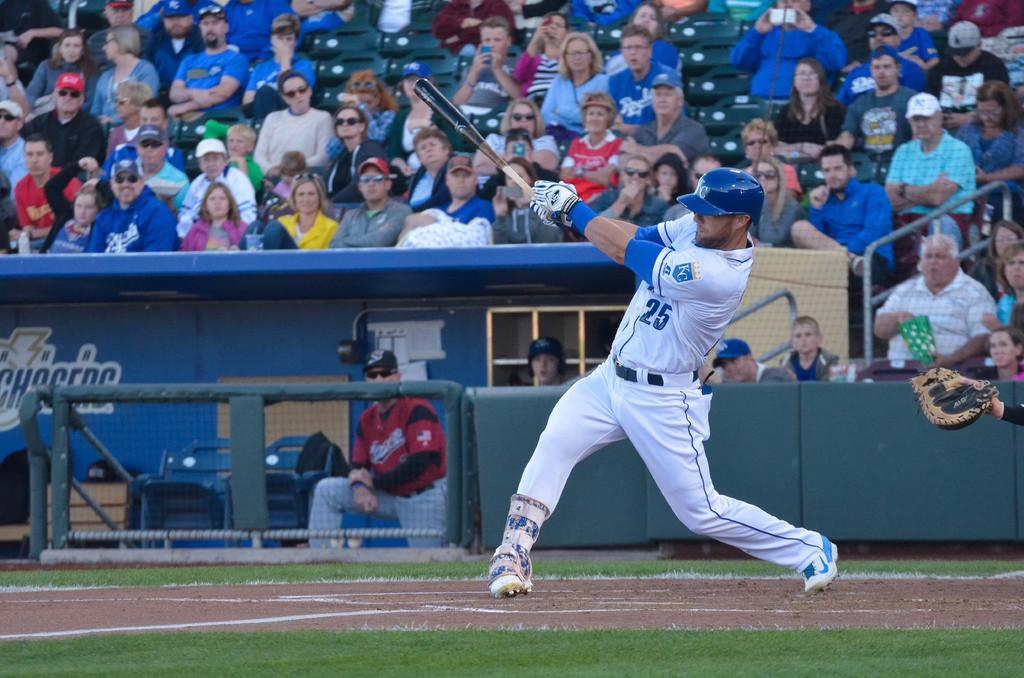<image>
Present a compact description of the photo's key features. The player at bat is wearing the number 25 